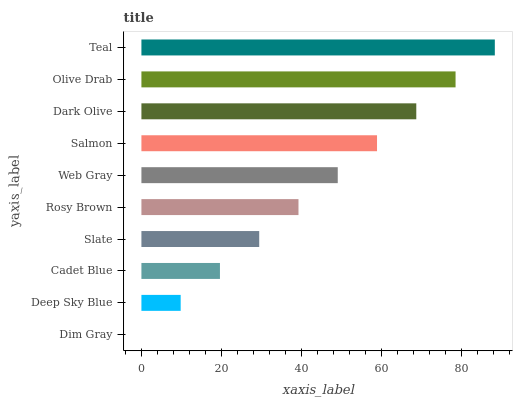Is Dim Gray the minimum?
Answer yes or no. Yes. Is Teal the maximum?
Answer yes or no. Yes. Is Deep Sky Blue the minimum?
Answer yes or no. No. Is Deep Sky Blue the maximum?
Answer yes or no. No. Is Deep Sky Blue greater than Dim Gray?
Answer yes or no. Yes. Is Dim Gray less than Deep Sky Blue?
Answer yes or no. Yes. Is Dim Gray greater than Deep Sky Blue?
Answer yes or no. No. Is Deep Sky Blue less than Dim Gray?
Answer yes or no. No. Is Web Gray the high median?
Answer yes or no. Yes. Is Rosy Brown the low median?
Answer yes or no. Yes. Is Dim Gray the high median?
Answer yes or no. No. Is Dark Olive the low median?
Answer yes or no. No. 